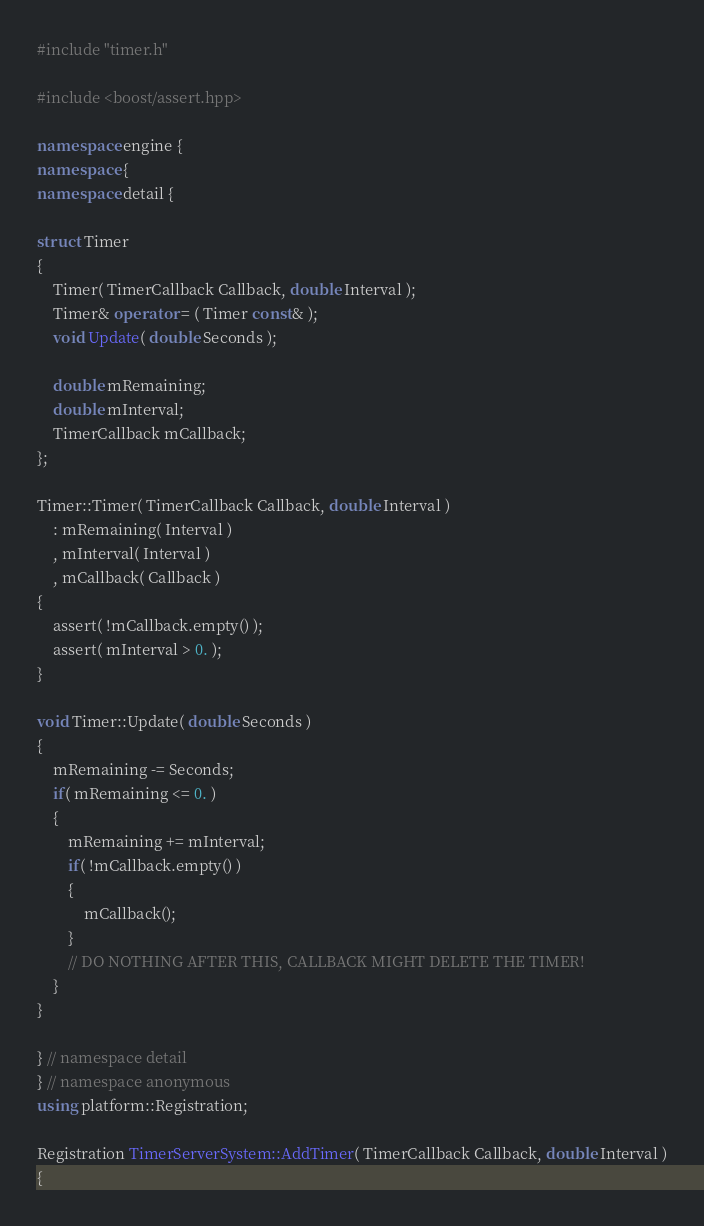Convert code to text. <code><loc_0><loc_0><loc_500><loc_500><_C++_>#include "timer.h"

#include <boost/assert.hpp>

namespace engine {
namespace {
namespace detail {

struct Timer
{
    Timer( TimerCallback Callback, double Interval );
    Timer& operator = ( Timer const& );
    void Update( double Seconds );

    double mRemaining;
    double mInterval;
    TimerCallback mCallback;
};

Timer::Timer( TimerCallback Callback, double Interval )
    : mRemaining( Interval )
    , mInterval( Interval )
    , mCallback( Callback )
{
    assert( !mCallback.empty() );
    assert( mInterval > 0. );
}

void Timer::Update( double Seconds )
{
    mRemaining -= Seconds;
    if( mRemaining <= 0. )
    {
        mRemaining += mInterval;
        if( !mCallback.empty() )
        {
            mCallback();
        }
        // DO NOTHING AFTER THIS, CALLBACK MIGHT DELETE THE TIMER!
    }
}

} // namespace detail
} // namespace anonymous
using platform::Registration;

Registration TimerServerSystem::AddTimer( TimerCallback Callback, double Interval )
{</code> 